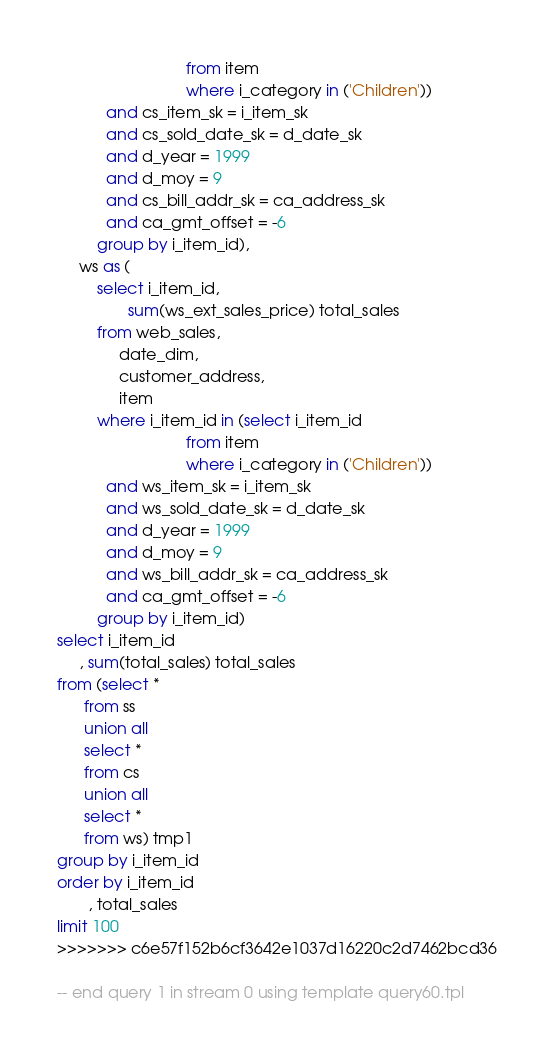Convert code to text. <code><loc_0><loc_0><loc_500><loc_500><_SQL_>                             from item
                             where i_category in ('Children'))
           and cs_item_sk = i_item_sk
           and cs_sold_date_sk = d_date_sk
           and d_year = 1999
           and d_moy = 9
           and cs_bill_addr_sk = ca_address_sk
           and ca_gmt_offset = -6
         group by i_item_id),
     ws as (
         select i_item_id,
                sum(ws_ext_sales_price) total_sales
         from web_sales,
              date_dim,
              customer_address,
              item
         where i_item_id in (select i_item_id
                             from item
                             where i_category in ('Children'))
           and ws_item_sk = i_item_sk
           and ws_sold_date_sk = d_date_sk
           and d_year = 1999
           and d_moy = 9
           and ws_bill_addr_sk = ca_address_sk
           and ca_gmt_offset = -6
         group by i_item_id)
select i_item_id
     , sum(total_sales) total_sales
from (select *
      from ss
      union all
      select *
      from cs
      union all
      select *
      from ws) tmp1
group by i_item_id
order by i_item_id
       , total_sales
limit 100
>>>>>>> c6e57f152b6cf3642e1037d16220c2d7462bcd36

-- end query 1 in stream 0 using template query60.tpl
</code> 